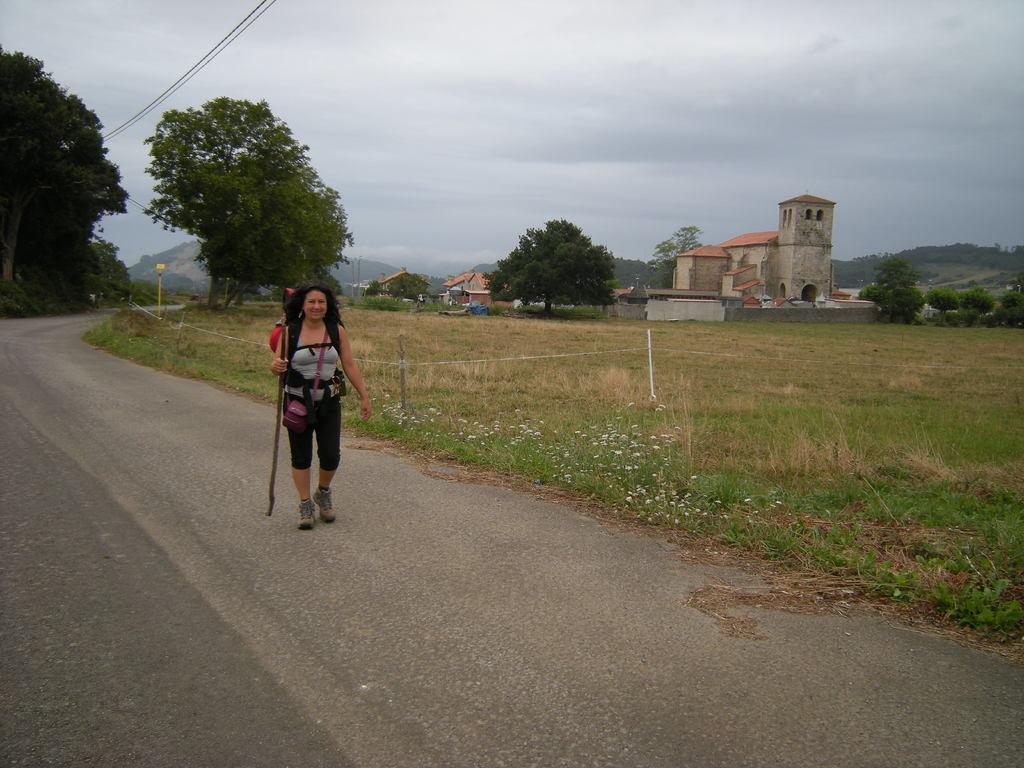Could you give a brief overview of what you see in this image? In the image there is a lady with grey t-shirt, black short and holding the stick in her is walking on the road. Beside her there is a ground with grass, flowers and poles. In the background there are trees and buildings with walls, windows and roof. At the top of the image there is a sky with clouds and wires. 